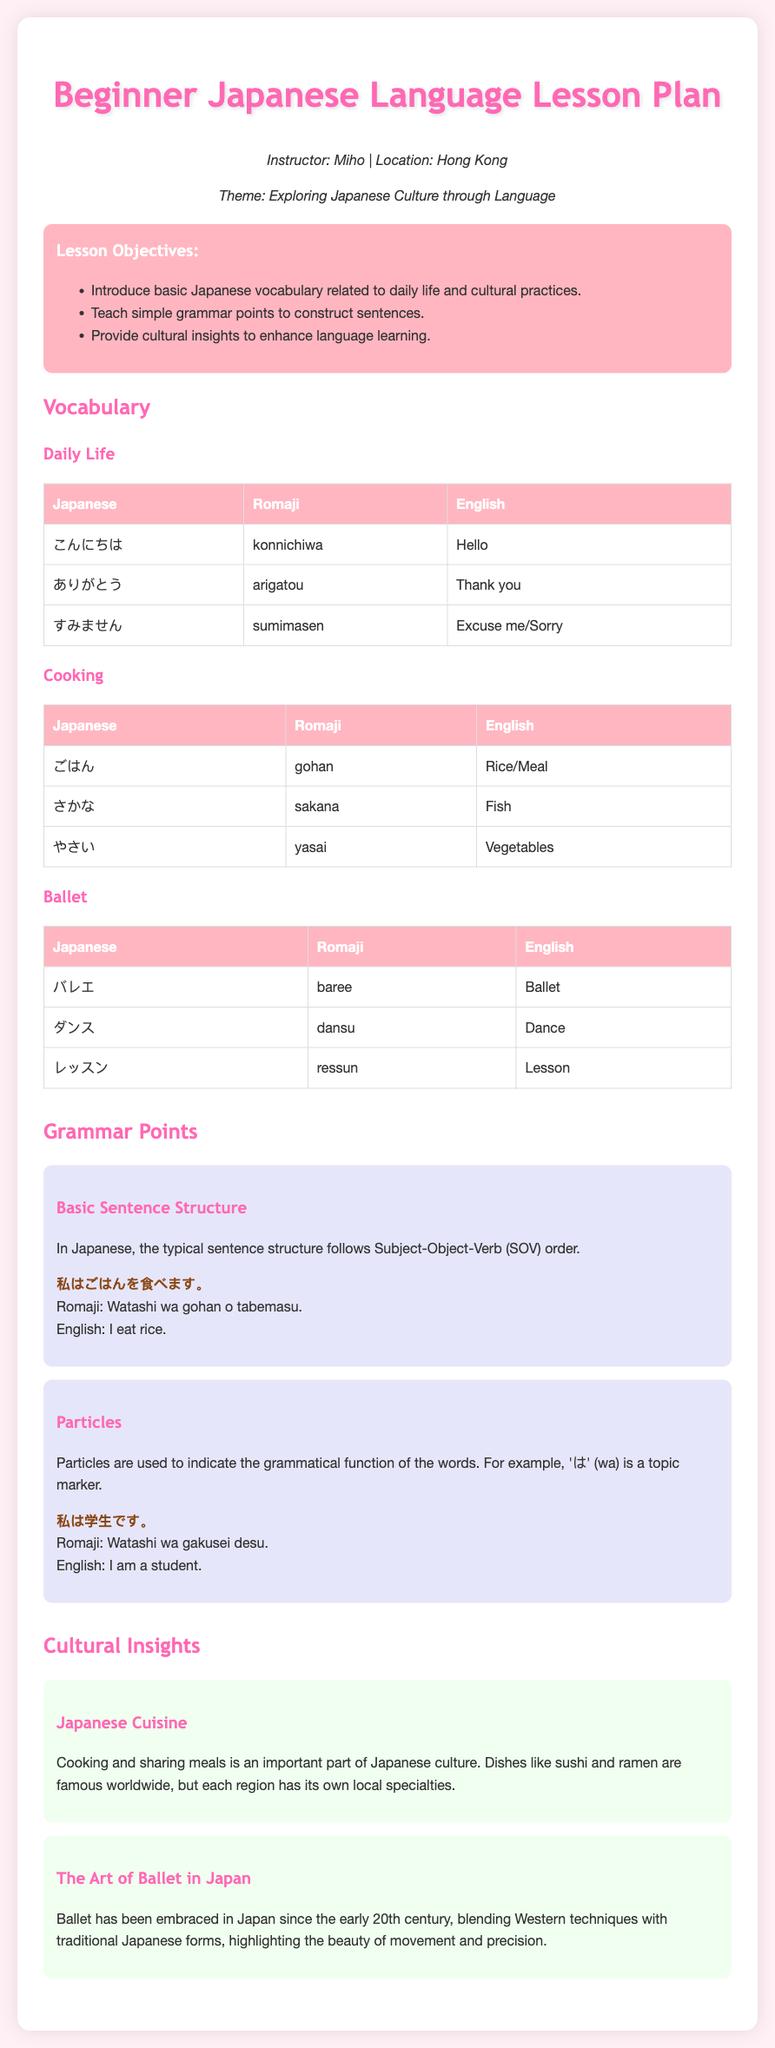what is the instructor's name? The instructor's name is mentioned at the top of the document in the instructor info section.
Answer: Miho what is the lesson's theme? The theme is presented in the instructor info section of the document.
Answer: Exploring Japanese Culture through Language what are the three main lesson objectives? The objectives are listed in the objectives section of the document.
Answer: Introduce basic Japanese vocabulary related to daily life and cultural practices, Teach simple grammar points to construct sentences, Provide cultural insights to enhance language learning how many vocabulary categories are included? The categories can be counted from the vocabulary section headings.
Answer: Three what is the Japanese term for "thank you"? The term can be found in the vocabulary table under daily life.
Answer: ありがとう what is the basic sentence structure in Japanese? The basic sentence structure is provided in the grammar points section.
Answer: Subject-Object-Verb what particle is used as a topic marker? The particle is mentioned in the explanation of the grammar points regarding particles.
Answer: は how has ballet been embraced in Japan? The cultural insight section discusses this aspect of ballet in Japan.
Answer: Blending Western techniques with traditional Japanese forms what food is known as an important part of Japanese culture? This information can be found in the cultural insights section regarding Japanese cuisine.
Answer: Cooking and sharing meals what is the English translation of "ごはん"? The translation is provided in the cooking vocabulary table.
Answer: Rice/Meal 